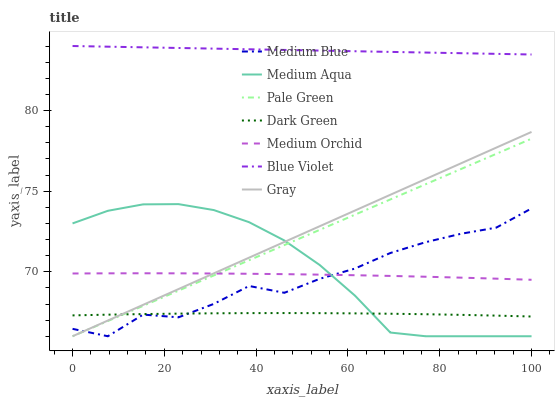Does Dark Green have the minimum area under the curve?
Answer yes or no. Yes. Does Blue Violet have the maximum area under the curve?
Answer yes or no. Yes. Does Medium Orchid have the minimum area under the curve?
Answer yes or no. No. Does Medium Orchid have the maximum area under the curve?
Answer yes or no. No. Is Pale Green the smoothest?
Answer yes or no. Yes. Is Medium Blue the roughest?
Answer yes or no. Yes. Is Medium Orchid the smoothest?
Answer yes or no. No. Is Medium Orchid the roughest?
Answer yes or no. No. Does Gray have the lowest value?
Answer yes or no. Yes. Does Medium Orchid have the lowest value?
Answer yes or no. No. Does Blue Violet have the highest value?
Answer yes or no. Yes. Does Medium Orchid have the highest value?
Answer yes or no. No. Is Medium Blue less than Blue Violet?
Answer yes or no. Yes. Is Blue Violet greater than Medium Aqua?
Answer yes or no. Yes. Does Medium Aqua intersect Medium Orchid?
Answer yes or no. Yes. Is Medium Aqua less than Medium Orchid?
Answer yes or no. No. Is Medium Aqua greater than Medium Orchid?
Answer yes or no. No. Does Medium Blue intersect Blue Violet?
Answer yes or no. No. 